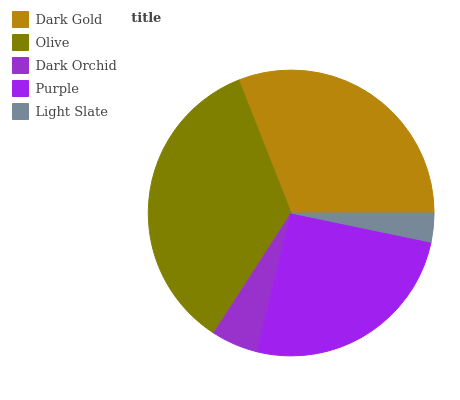Is Light Slate the minimum?
Answer yes or no. Yes. Is Olive the maximum?
Answer yes or no. Yes. Is Dark Orchid the minimum?
Answer yes or no. No. Is Dark Orchid the maximum?
Answer yes or no. No. Is Olive greater than Dark Orchid?
Answer yes or no. Yes. Is Dark Orchid less than Olive?
Answer yes or no. Yes. Is Dark Orchid greater than Olive?
Answer yes or no. No. Is Olive less than Dark Orchid?
Answer yes or no. No. Is Purple the high median?
Answer yes or no. Yes. Is Purple the low median?
Answer yes or no. Yes. Is Olive the high median?
Answer yes or no. No. Is Dark Gold the low median?
Answer yes or no. No. 